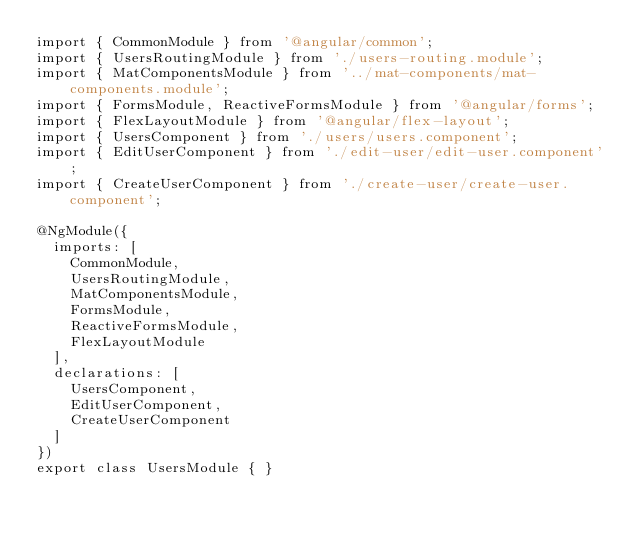<code> <loc_0><loc_0><loc_500><loc_500><_TypeScript_>import { CommonModule } from '@angular/common';
import { UsersRoutingModule } from './users-routing.module';
import { MatComponentsModule } from '../mat-components/mat-components.module';
import { FormsModule, ReactiveFormsModule } from '@angular/forms';
import { FlexLayoutModule } from '@angular/flex-layout';
import { UsersComponent } from './users/users.component';
import { EditUserComponent } from './edit-user/edit-user.component';
import { CreateUserComponent } from './create-user/create-user.component';

@NgModule({
  imports: [
    CommonModule,
    UsersRoutingModule,
    MatComponentsModule,
    FormsModule,
    ReactiveFormsModule,
    FlexLayoutModule
  ],
  declarations: [
    UsersComponent,
    EditUserComponent,
    CreateUserComponent
  ]
})
export class UsersModule { }
</code> 